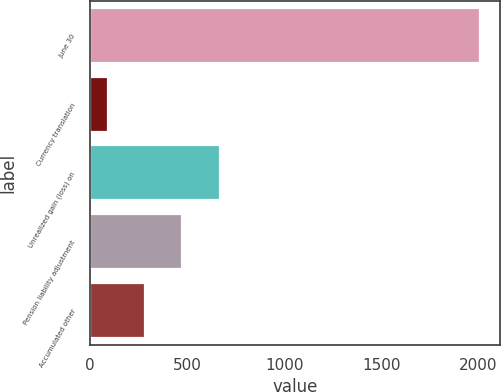Convert chart to OTSL. <chart><loc_0><loc_0><loc_500><loc_500><bar_chart><fcel>June 30<fcel>Currency translation<fcel>Unrealized gain (loss) on<fcel>Pension liability adjustment<fcel>Accumulated other<nl><fcel>2009<fcel>92.5<fcel>667.45<fcel>475.8<fcel>284.15<nl></chart> 